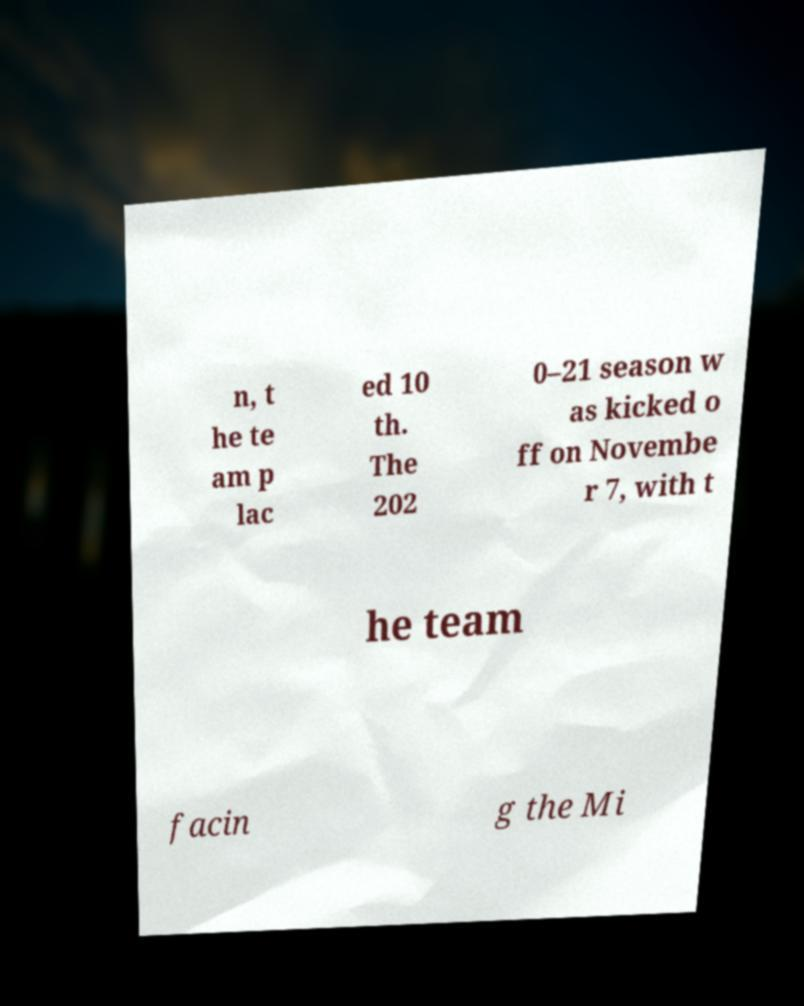What messages or text are displayed in this image? I need them in a readable, typed format. n, t he te am p lac ed 10 th. The 202 0–21 season w as kicked o ff on Novembe r 7, with t he team facin g the Mi 